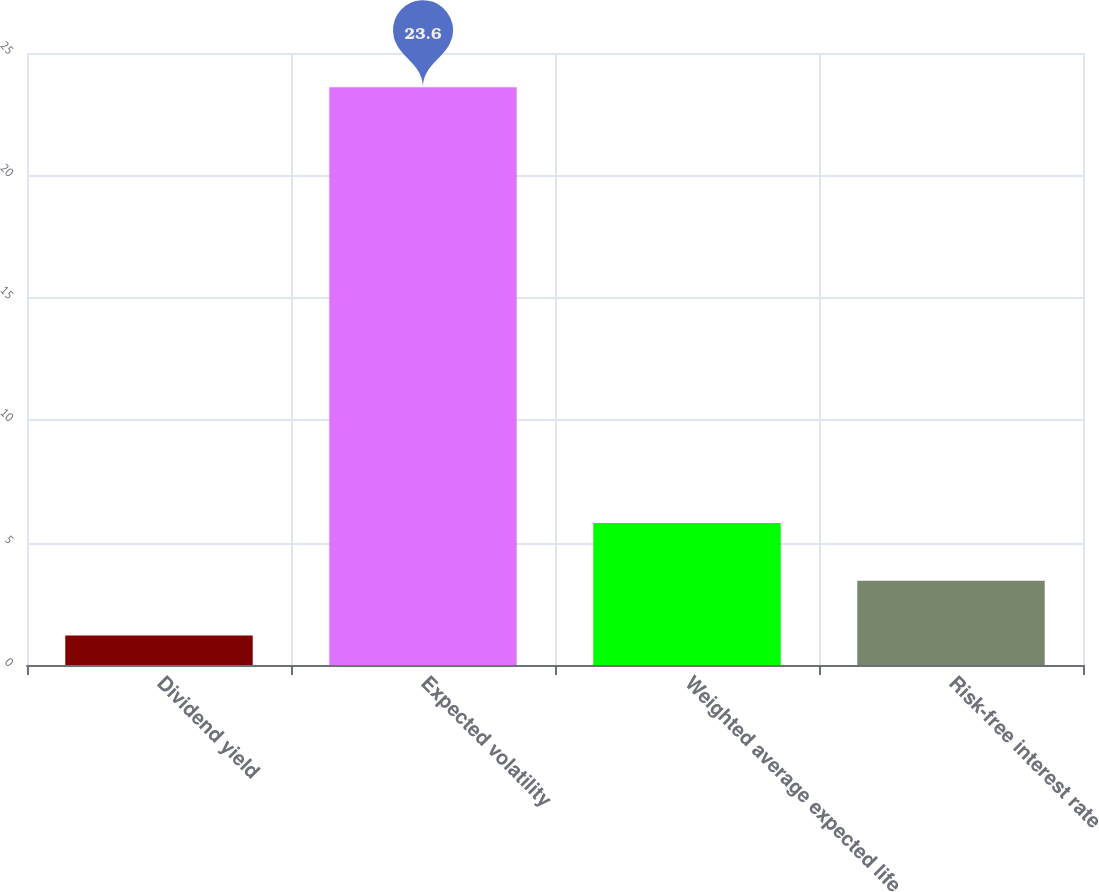<chart> <loc_0><loc_0><loc_500><loc_500><bar_chart><fcel>Dividend yield<fcel>Expected volatility<fcel>Weighted average expected life<fcel>Risk-free interest rate<nl><fcel>1.2<fcel>23.6<fcel>5.8<fcel>3.44<nl></chart> 